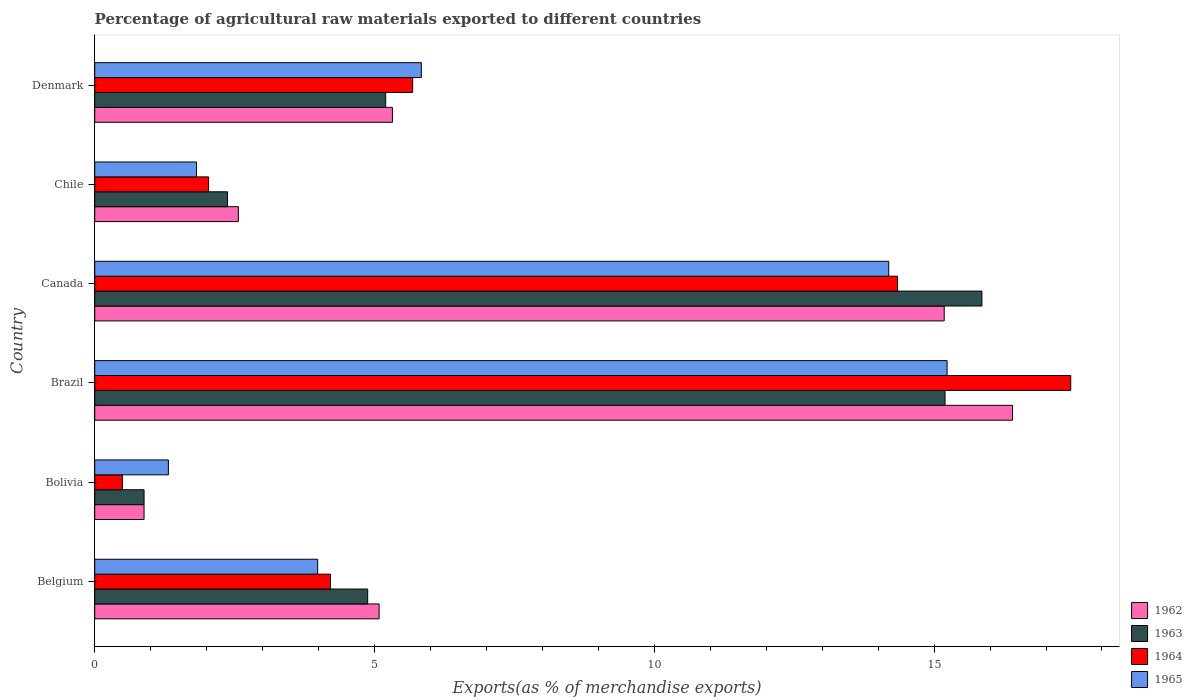How many groups of bars are there?
Offer a very short reply. 6. Are the number of bars per tick equal to the number of legend labels?
Offer a very short reply. Yes. How many bars are there on the 5th tick from the top?
Your answer should be very brief. 4. How many bars are there on the 1st tick from the bottom?
Give a very brief answer. 4. What is the label of the 2nd group of bars from the top?
Keep it short and to the point. Chile. In how many cases, is the number of bars for a given country not equal to the number of legend labels?
Offer a very short reply. 0. What is the percentage of exports to different countries in 1963 in Belgium?
Keep it short and to the point. 4.88. Across all countries, what is the maximum percentage of exports to different countries in 1962?
Give a very brief answer. 16.4. Across all countries, what is the minimum percentage of exports to different countries in 1965?
Your response must be concise. 1.32. In which country was the percentage of exports to different countries in 1964 maximum?
Make the answer very short. Brazil. What is the total percentage of exports to different countries in 1965 in the graph?
Your answer should be compact. 42.38. What is the difference between the percentage of exports to different countries in 1964 in Belgium and that in Denmark?
Offer a terse response. -1.47. What is the difference between the percentage of exports to different countries in 1962 in Denmark and the percentage of exports to different countries in 1964 in Canada?
Keep it short and to the point. -9.03. What is the average percentage of exports to different countries in 1965 per country?
Offer a very short reply. 7.06. What is the difference between the percentage of exports to different countries in 1963 and percentage of exports to different countries in 1964 in Canada?
Make the answer very short. 1.51. In how many countries, is the percentage of exports to different countries in 1965 greater than 17 %?
Ensure brevity in your answer.  0. What is the ratio of the percentage of exports to different countries in 1963 in Bolivia to that in Brazil?
Provide a short and direct response. 0.06. Is the percentage of exports to different countries in 1964 in Bolivia less than that in Denmark?
Offer a very short reply. Yes. What is the difference between the highest and the second highest percentage of exports to different countries in 1964?
Offer a terse response. 3.1. What is the difference between the highest and the lowest percentage of exports to different countries in 1963?
Your answer should be compact. 14.97. In how many countries, is the percentage of exports to different countries in 1965 greater than the average percentage of exports to different countries in 1965 taken over all countries?
Provide a succinct answer. 2. What does the 3rd bar from the top in Belgium represents?
Offer a terse response. 1963. What does the 1st bar from the bottom in Brazil represents?
Provide a succinct answer. 1962. How many countries are there in the graph?
Offer a terse response. 6. What is the difference between two consecutive major ticks on the X-axis?
Keep it short and to the point. 5. How many legend labels are there?
Ensure brevity in your answer.  4. What is the title of the graph?
Make the answer very short. Percentage of agricultural raw materials exported to different countries. What is the label or title of the X-axis?
Keep it short and to the point. Exports(as % of merchandise exports). What is the Exports(as % of merchandise exports) in 1962 in Belgium?
Your answer should be compact. 5.08. What is the Exports(as % of merchandise exports) of 1963 in Belgium?
Offer a very short reply. 4.88. What is the Exports(as % of merchandise exports) of 1964 in Belgium?
Offer a very short reply. 4.21. What is the Exports(as % of merchandise exports) in 1965 in Belgium?
Provide a short and direct response. 3.98. What is the Exports(as % of merchandise exports) in 1962 in Bolivia?
Offer a terse response. 0.88. What is the Exports(as % of merchandise exports) of 1963 in Bolivia?
Your answer should be very brief. 0.88. What is the Exports(as % of merchandise exports) in 1964 in Bolivia?
Your answer should be compact. 0.49. What is the Exports(as % of merchandise exports) of 1965 in Bolivia?
Keep it short and to the point. 1.32. What is the Exports(as % of merchandise exports) in 1962 in Brazil?
Offer a terse response. 16.4. What is the Exports(as % of merchandise exports) in 1963 in Brazil?
Your answer should be very brief. 15.2. What is the Exports(as % of merchandise exports) in 1964 in Brazil?
Offer a terse response. 17.44. What is the Exports(as % of merchandise exports) of 1965 in Brazil?
Offer a terse response. 15.23. What is the Exports(as % of merchandise exports) of 1962 in Canada?
Ensure brevity in your answer.  15.18. What is the Exports(as % of merchandise exports) in 1963 in Canada?
Your answer should be compact. 15.85. What is the Exports(as % of merchandise exports) of 1964 in Canada?
Offer a terse response. 14.35. What is the Exports(as % of merchandise exports) of 1965 in Canada?
Provide a succinct answer. 14.19. What is the Exports(as % of merchandise exports) of 1962 in Chile?
Your answer should be compact. 2.57. What is the Exports(as % of merchandise exports) of 1963 in Chile?
Keep it short and to the point. 2.37. What is the Exports(as % of merchandise exports) in 1964 in Chile?
Ensure brevity in your answer.  2.03. What is the Exports(as % of merchandise exports) of 1965 in Chile?
Provide a short and direct response. 1.82. What is the Exports(as % of merchandise exports) in 1962 in Denmark?
Your answer should be very brief. 5.32. What is the Exports(as % of merchandise exports) of 1963 in Denmark?
Provide a short and direct response. 5.2. What is the Exports(as % of merchandise exports) of 1964 in Denmark?
Your answer should be compact. 5.68. What is the Exports(as % of merchandise exports) in 1965 in Denmark?
Make the answer very short. 5.84. Across all countries, what is the maximum Exports(as % of merchandise exports) of 1962?
Offer a terse response. 16.4. Across all countries, what is the maximum Exports(as % of merchandise exports) of 1963?
Your response must be concise. 15.85. Across all countries, what is the maximum Exports(as % of merchandise exports) of 1964?
Provide a short and direct response. 17.44. Across all countries, what is the maximum Exports(as % of merchandise exports) in 1965?
Your answer should be very brief. 15.23. Across all countries, what is the minimum Exports(as % of merchandise exports) in 1962?
Keep it short and to the point. 0.88. Across all countries, what is the minimum Exports(as % of merchandise exports) of 1963?
Offer a very short reply. 0.88. Across all countries, what is the minimum Exports(as % of merchandise exports) of 1964?
Your answer should be very brief. 0.49. Across all countries, what is the minimum Exports(as % of merchandise exports) of 1965?
Keep it short and to the point. 1.32. What is the total Exports(as % of merchandise exports) of 1962 in the graph?
Your answer should be very brief. 45.43. What is the total Exports(as % of merchandise exports) of 1963 in the graph?
Your answer should be very brief. 44.38. What is the total Exports(as % of merchandise exports) in 1964 in the graph?
Provide a short and direct response. 44.21. What is the total Exports(as % of merchandise exports) in 1965 in the graph?
Provide a short and direct response. 42.38. What is the difference between the Exports(as % of merchandise exports) in 1962 in Belgium and that in Bolivia?
Offer a very short reply. 4.2. What is the difference between the Exports(as % of merchandise exports) in 1963 in Belgium and that in Bolivia?
Your answer should be very brief. 4. What is the difference between the Exports(as % of merchandise exports) of 1964 in Belgium and that in Bolivia?
Keep it short and to the point. 3.72. What is the difference between the Exports(as % of merchandise exports) of 1965 in Belgium and that in Bolivia?
Ensure brevity in your answer.  2.67. What is the difference between the Exports(as % of merchandise exports) in 1962 in Belgium and that in Brazil?
Make the answer very short. -11.32. What is the difference between the Exports(as % of merchandise exports) of 1963 in Belgium and that in Brazil?
Keep it short and to the point. -10.32. What is the difference between the Exports(as % of merchandise exports) of 1964 in Belgium and that in Brazil?
Your answer should be compact. -13.23. What is the difference between the Exports(as % of merchandise exports) in 1965 in Belgium and that in Brazil?
Provide a short and direct response. -11.25. What is the difference between the Exports(as % of merchandise exports) of 1962 in Belgium and that in Canada?
Offer a very short reply. -10.1. What is the difference between the Exports(as % of merchandise exports) of 1963 in Belgium and that in Canada?
Ensure brevity in your answer.  -10.98. What is the difference between the Exports(as % of merchandise exports) in 1964 in Belgium and that in Canada?
Offer a terse response. -10.13. What is the difference between the Exports(as % of merchandise exports) of 1965 in Belgium and that in Canada?
Provide a succinct answer. -10.21. What is the difference between the Exports(as % of merchandise exports) in 1962 in Belgium and that in Chile?
Offer a terse response. 2.52. What is the difference between the Exports(as % of merchandise exports) in 1963 in Belgium and that in Chile?
Your answer should be very brief. 2.5. What is the difference between the Exports(as % of merchandise exports) in 1964 in Belgium and that in Chile?
Give a very brief answer. 2.18. What is the difference between the Exports(as % of merchandise exports) in 1965 in Belgium and that in Chile?
Offer a very short reply. 2.17. What is the difference between the Exports(as % of merchandise exports) in 1962 in Belgium and that in Denmark?
Make the answer very short. -0.24. What is the difference between the Exports(as % of merchandise exports) of 1963 in Belgium and that in Denmark?
Your answer should be very brief. -0.32. What is the difference between the Exports(as % of merchandise exports) of 1964 in Belgium and that in Denmark?
Make the answer very short. -1.47. What is the difference between the Exports(as % of merchandise exports) in 1965 in Belgium and that in Denmark?
Offer a terse response. -1.85. What is the difference between the Exports(as % of merchandise exports) of 1962 in Bolivia and that in Brazil?
Keep it short and to the point. -15.52. What is the difference between the Exports(as % of merchandise exports) of 1963 in Bolivia and that in Brazil?
Keep it short and to the point. -14.31. What is the difference between the Exports(as % of merchandise exports) in 1964 in Bolivia and that in Brazil?
Offer a terse response. -16.95. What is the difference between the Exports(as % of merchandise exports) of 1965 in Bolivia and that in Brazil?
Your answer should be very brief. -13.92. What is the difference between the Exports(as % of merchandise exports) of 1962 in Bolivia and that in Canada?
Make the answer very short. -14.3. What is the difference between the Exports(as % of merchandise exports) of 1963 in Bolivia and that in Canada?
Ensure brevity in your answer.  -14.97. What is the difference between the Exports(as % of merchandise exports) in 1964 in Bolivia and that in Canada?
Provide a short and direct response. -13.85. What is the difference between the Exports(as % of merchandise exports) in 1965 in Bolivia and that in Canada?
Give a very brief answer. -12.87. What is the difference between the Exports(as % of merchandise exports) of 1962 in Bolivia and that in Chile?
Your answer should be very brief. -1.69. What is the difference between the Exports(as % of merchandise exports) of 1963 in Bolivia and that in Chile?
Offer a very short reply. -1.49. What is the difference between the Exports(as % of merchandise exports) of 1964 in Bolivia and that in Chile?
Provide a short and direct response. -1.54. What is the difference between the Exports(as % of merchandise exports) of 1965 in Bolivia and that in Chile?
Offer a very short reply. -0.5. What is the difference between the Exports(as % of merchandise exports) in 1962 in Bolivia and that in Denmark?
Your answer should be very brief. -4.44. What is the difference between the Exports(as % of merchandise exports) of 1963 in Bolivia and that in Denmark?
Your answer should be very brief. -4.32. What is the difference between the Exports(as % of merchandise exports) in 1964 in Bolivia and that in Denmark?
Ensure brevity in your answer.  -5.19. What is the difference between the Exports(as % of merchandise exports) of 1965 in Bolivia and that in Denmark?
Make the answer very short. -4.52. What is the difference between the Exports(as % of merchandise exports) of 1962 in Brazil and that in Canada?
Provide a succinct answer. 1.22. What is the difference between the Exports(as % of merchandise exports) in 1963 in Brazil and that in Canada?
Offer a terse response. -0.66. What is the difference between the Exports(as % of merchandise exports) in 1964 in Brazil and that in Canada?
Provide a short and direct response. 3.1. What is the difference between the Exports(as % of merchandise exports) in 1965 in Brazil and that in Canada?
Your answer should be compact. 1.04. What is the difference between the Exports(as % of merchandise exports) in 1962 in Brazil and that in Chile?
Your response must be concise. 13.84. What is the difference between the Exports(as % of merchandise exports) in 1963 in Brazil and that in Chile?
Provide a short and direct response. 12.82. What is the difference between the Exports(as % of merchandise exports) in 1964 in Brazil and that in Chile?
Your answer should be compact. 15.41. What is the difference between the Exports(as % of merchandise exports) in 1965 in Brazil and that in Chile?
Provide a short and direct response. 13.41. What is the difference between the Exports(as % of merchandise exports) in 1962 in Brazil and that in Denmark?
Offer a very short reply. 11.08. What is the difference between the Exports(as % of merchandise exports) of 1963 in Brazil and that in Denmark?
Keep it short and to the point. 10. What is the difference between the Exports(as % of merchandise exports) of 1964 in Brazil and that in Denmark?
Ensure brevity in your answer.  11.76. What is the difference between the Exports(as % of merchandise exports) of 1965 in Brazil and that in Denmark?
Offer a terse response. 9.4. What is the difference between the Exports(as % of merchandise exports) in 1962 in Canada and that in Chile?
Offer a terse response. 12.61. What is the difference between the Exports(as % of merchandise exports) in 1963 in Canada and that in Chile?
Provide a succinct answer. 13.48. What is the difference between the Exports(as % of merchandise exports) of 1964 in Canada and that in Chile?
Make the answer very short. 12.31. What is the difference between the Exports(as % of merchandise exports) of 1965 in Canada and that in Chile?
Ensure brevity in your answer.  12.37. What is the difference between the Exports(as % of merchandise exports) in 1962 in Canada and that in Denmark?
Provide a short and direct response. 9.86. What is the difference between the Exports(as % of merchandise exports) of 1963 in Canada and that in Denmark?
Your response must be concise. 10.65. What is the difference between the Exports(as % of merchandise exports) of 1964 in Canada and that in Denmark?
Provide a short and direct response. 8.66. What is the difference between the Exports(as % of merchandise exports) of 1965 in Canada and that in Denmark?
Your answer should be compact. 8.35. What is the difference between the Exports(as % of merchandise exports) of 1962 in Chile and that in Denmark?
Offer a very short reply. -2.75. What is the difference between the Exports(as % of merchandise exports) in 1963 in Chile and that in Denmark?
Offer a terse response. -2.83. What is the difference between the Exports(as % of merchandise exports) in 1964 in Chile and that in Denmark?
Your answer should be compact. -3.65. What is the difference between the Exports(as % of merchandise exports) of 1965 in Chile and that in Denmark?
Your answer should be very brief. -4.02. What is the difference between the Exports(as % of merchandise exports) of 1962 in Belgium and the Exports(as % of merchandise exports) of 1963 in Bolivia?
Keep it short and to the point. 4.2. What is the difference between the Exports(as % of merchandise exports) in 1962 in Belgium and the Exports(as % of merchandise exports) in 1964 in Bolivia?
Provide a short and direct response. 4.59. What is the difference between the Exports(as % of merchandise exports) in 1962 in Belgium and the Exports(as % of merchandise exports) in 1965 in Bolivia?
Provide a succinct answer. 3.77. What is the difference between the Exports(as % of merchandise exports) of 1963 in Belgium and the Exports(as % of merchandise exports) of 1964 in Bolivia?
Your answer should be very brief. 4.38. What is the difference between the Exports(as % of merchandise exports) of 1963 in Belgium and the Exports(as % of merchandise exports) of 1965 in Bolivia?
Provide a succinct answer. 3.56. What is the difference between the Exports(as % of merchandise exports) in 1964 in Belgium and the Exports(as % of merchandise exports) in 1965 in Bolivia?
Your answer should be very brief. 2.9. What is the difference between the Exports(as % of merchandise exports) of 1962 in Belgium and the Exports(as % of merchandise exports) of 1963 in Brazil?
Give a very brief answer. -10.11. What is the difference between the Exports(as % of merchandise exports) in 1962 in Belgium and the Exports(as % of merchandise exports) in 1964 in Brazil?
Provide a short and direct response. -12.36. What is the difference between the Exports(as % of merchandise exports) in 1962 in Belgium and the Exports(as % of merchandise exports) in 1965 in Brazil?
Ensure brevity in your answer.  -10.15. What is the difference between the Exports(as % of merchandise exports) in 1963 in Belgium and the Exports(as % of merchandise exports) in 1964 in Brazil?
Offer a very short reply. -12.56. What is the difference between the Exports(as % of merchandise exports) of 1963 in Belgium and the Exports(as % of merchandise exports) of 1965 in Brazil?
Offer a very short reply. -10.35. What is the difference between the Exports(as % of merchandise exports) of 1964 in Belgium and the Exports(as % of merchandise exports) of 1965 in Brazil?
Your answer should be compact. -11.02. What is the difference between the Exports(as % of merchandise exports) of 1962 in Belgium and the Exports(as % of merchandise exports) of 1963 in Canada?
Keep it short and to the point. -10.77. What is the difference between the Exports(as % of merchandise exports) of 1962 in Belgium and the Exports(as % of merchandise exports) of 1964 in Canada?
Make the answer very short. -9.26. What is the difference between the Exports(as % of merchandise exports) of 1962 in Belgium and the Exports(as % of merchandise exports) of 1965 in Canada?
Make the answer very short. -9.11. What is the difference between the Exports(as % of merchandise exports) of 1963 in Belgium and the Exports(as % of merchandise exports) of 1964 in Canada?
Provide a succinct answer. -9.47. What is the difference between the Exports(as % of merchandise exports) of 1963 in Belgium and the Exports(as % of merchandise exports) of 1965 in Canada?
Provide a short and direct response. -9.31. What is the difference between the Exports(as % of merchandise exports) of 1964 in Belgium and the Exports(as % of merchandise exports) of 1965 in Canada?
Offer a very short reply. -9.98. What is the difference between the Exports(as % of merchandise exports) in 1962 in Belgium and the Exports(as % of merchandise exports) in 1963 in Chile?
Offer a terse response. 2.71. What is the difference between the Exports(as % of merchandise exports) of 1962 in Belgium and the Exports(as % of merchandise exports) of 1964 in Chile?
Your response must be concise. 3.05. What is the difference between the Exports(as % of merchandise exports) of 1962 in Belgium and the Exports(as % of merchandise exports) of 1965 in Chile?
Give a very brief answer. 3.26. What is the difference between the Exports(as % of merchandise exports) in 1963 in Belgium and the Exports(as % of merchandise exports) in 1964 in Chile?
Provide a short and direct response. 2.84. What is the difference between the Exports(as % of merchandise exports) in 1963 in Belgium and the Exports(as % of merchandise exports) in 1965 in Chile?
Provide a short and direct response. 3.06. What is the difference between the Exports(as % of merchandise exports) of 1964 in Belgium and the Exports(as % of merchandise exports) of 1965 in Chile?
Offer a very short reply. 2.4. What is the difference between the Exports(as % of merchandise exports) in 1962 in Belgium and the Exports(as % of merchandise exports) in 1963 in Denmark?
Offer a very short reply. -0.12. What is the difference between the Exports(as % of merchandise exports) in 1962 in Belgium and the Exports(as % of merchandise exports) in 1964 in Denmark?
Offer a very short reply. -0.6. What is the difference between the Exports(as % of merchandise exports) in 1962 in Belgium and the Exports(as % of merchandise exports) in 1965 in Denmark?
Your answer should be compact. -0.75. What is the difference between the Exports(as % of merchandise exports) of 1963 in Belgium and the Exports(as % of merchandise exports) of 1964 in Denmark?
Offer a terse response. -0.8. What is the difference between the Exports(as % of merchandise exports) in 1963 in Belgium and the Exports(as % of merchandise exports) in 1965 in Denmark?
Your answer should be very brief. -0.96. What is the difference between the Exports(as % of merchandise exports) in 1964 in Belgium and the Exports(as % of merchandise exports) in 1965 in Denmark?
Provide a short and direct response. -1.62. What is the difference between the Exports(as % of merchandise exports) in 1962 in Bolivia and the Exports(as % of merchandise exports) in 1963 in Brazil?
Your response must be concise. -14.31. What is the difference between the Exports(as % of merchandise exports) of 1962 in Bolivia and the Exports(as % of merchandise exports) of 1964 in Brazil?
Offer a terse response. -16.56. What is the difference between the Exports(as % of merchandise exports) of 1962 in Bolivia and the Exports(as % of merchandise exports) of 1965 in Brazil?
Offer a terse response. -14.35. What is the difference between the Exports(as % of merchandise exports) of 1963 in Bolivia and the Exports(as % of merchandise exports) of 1964 in Brazil?
Give a very brief answer. -16.56. What is the difference between the Exports(as % of merchandise exports) in 1963 in Bolivia and the Exports(as % of merchandise exports) in 1965 in Brazil?
Give a very brief answer. -14.35. What is the difference between the Exports(as % of merchandise exports) in 1964 in Bolivia and the Exports(as % of merchandise exports) in 1965 in Brazil?
Your answer should be compact. -14.74. What is the difference between the Exports(as % of merchandise exports) of 1962 in Bolivia and the Exports(as % of merchandise exports) of 1963 in Canada?
Provide a short and direct response. -14.97. What is the difference between the Exports(as % of merchandise exports) in 1962 in Bolivia and the Exports(as % of merchandise exports) in 1964 in Canada?
Offer a very short reply. -13.46. What is the difference between the Exports(as % of merchandise exports) in 1962 in Bolivia and the Exports(as % of merchandise exports) in 1965 in Canada?
Your answer should be very brief. -13.31. What is the difference between the Exports(as % of merchandise exports) of 1963 in Bolivia and the Exports(as % of merchandise exports) of 1964 in Canada?
Provide a succinct answer. -13.46. What is the difference between the Exports(as % of merchandise exports) of 1963 in Bolivia and the Exports(as % of merchandise exports) of 1965 in Canada?
Your response must be concise. -13.31. What is the difference between the Exports(as % of merchandise exports) in 1964 in Bolivia and the Exports(as % of merchandise exports) in 1965 in Canada?
Provide a short and direct response. -13.7. What is the difference between the Exports(as % of merchandise exports) in 1962 in Bolivia and the Exports(as % of merchandise exports) in 1963 in Chile?
Give a very brief answer. -1.49. What is the difference between the Exports(as % of merchandise exports) of 1962 in Bolivia and the Exports(as % of merchandise exports) of 1964 in Chile?
Make the answer very short. -1.15. What is the difference between the Exports(as % of merchandise exports) of 1962 in Bolivia and the Exports(as % of merchandise exports) of 1965 in Chile?
Provide a succinct answer. -0.94. What is the difference between the Exports(as % of merchandise exports) in 1963 in Bolivia and the Exports(as % of merchandise exports) in 1964 in Chile?
Provide a short and direct response. -1.15. What is the difference between the Exports(as % of merchandise exports) of 1963 in Bolivia and the Exports(as % of merchandise exports) of 1965 in Chile?
Offer a terse response. -0.94. What is the difference between the Exports(as % of merchandise exports) in 1964 in Bolivia and the Exports(as % of merchandise exports) in 1965 in Chile?
Your response must be concise. -1.32. What is the difference between the Exports(as % of merchandise exports) in 1962 in Bolivia and the Exports(as % of merchandise exports) in 1963 in Denmark?
Keep it short and to the point. -4.32. What is the difference between the Exports(as % of merchandise exports) of 1962 in Bolivia and the Exports(as % of merchandise exports) of 1964 in Denmark?
Provide a succinct answer. -4.8. What is the difference between the Exports(as % of merchandise exports) of 1962 in Bolivia and the Exports(as % of merchandise exports) of 1965 in Denmark?
Your answer should be compact. -4.95. What is the difference between the Exports(as % of merchandise exports) in 1963 in Bolivia and the Exports(as % of merchandise exports) in 1964 in Denmark?
Provide a short and direct response. -4.8. What is the difference between the Exports(as % of merchandise exports) in 1963 in Bolivia and the Exports(as % of merchandise exports) in 1965 in Denmark?
Make the answer very short. -4.95. What is the difference between the Exports(as % of merchandise exports) of 1964 in Bolivia and the Exports(as % of merchandise exports) of 1965 in Denmark?
Your response must be concise. -5.34. What is the difference between the Exports(as % of merchandise exports) in 1962 in Brazil and the Exports(as % of merchandise exports) in 1963 in Canada?
Offer a very short reply. 0.55. What is the difference between the Exports(as % of merchandise exports) of 1962 in Brazil and the Exports(as % of merchandise exports) of 1964 in Canada?
Keep it short and to the point. 2.06. What is the difference between the Exports(as % of merchandise exports) of 1962 in Brazil and the Exports(as % of merchandise exports) of 1965 in Canada?
Your answer should be compact. 2.21. What is the difference between the Exports(as % of merchandise exports) in 1963 in Brazil and the Exports(as % of merchandise exports) in 1964 in Canada?
Offer a very short reply. 0.85. What is the difference between the Exports(as % of merchandise exports) in 1963 in Brazil and the Exports(as % of merchandise exports) in 1965 in Canada?
Your response must be concise. 1.01. What is the difference between the Exports(as % of merchandise exports) of 1964 in Brazil and the Exports(as % of merchandise exports) of 1965 in Canada?
Make the answer very short. 3.25. What is the difference between the Exports(as % of merchandise exports) in 1962 in Brazil and the Exports(as % of merchandise exports) in 1963 in Chile?
Your response must be concise. 14.03. What is the difference between the Exports(as % of merchandise exports) of 1962 in Brazil and the Exports(as % of merchandise exports) of 1964 in Chile?
Ensure brevity in your answer.  14.37. What is the difference between the Exports(as % of merchandise exports) of 1962 in Brazil and the Exports(as % of merchandise exports) of 1965 in Chile?
Offer a very short reply. 14.58. What is the difference between the Exports(as % of merchandise exports) in 1963 in Brazil and the Exports(as % of merchandise exports) in 1964 in Chile?
Offer a very short reply. 13.16. What is the difference between the Exports(as % of merchandise exports) of 1963 in Brazil and the Exports(as % of merchandise exports) of 1965 in Chile?
Keep it short and to the point. 13.38. What is the difference between the Exports(as % of merchandise exports) in 1964 in Brazil and the Exports(as % of merchandise exports) in 1965 in Chile?
Your answer should be compact. 15.62. What is the difference between the Exports(as % of merchandise exports) of 1962 in Brazil and the Exports(as % of merchandise exports) of 1963 in Denmark?
Your answer should be very brief. 11.2. What is the difference between the Exports(as % of merchandise exports) of 1962 in Brazil and the Exports(as % of merchandise exports) of 1964 in Denmark?
Your answer should be compact. 10.72. What is the difference between the Exports(as % of merchandise exports) in 1962 in Brazil and the Exports(as % of merchandise exports) in 1965 in Denmark?
Offer a very short reply. 10.57. What is the difference between the Exports(as % of merchandise exports) of 1963 in Brazil and the Exports(as % of merchandise exports) of 1964 in Denmark?
Your response must be concise. 9.51. What is the difference between the Exports(as % of merchandise exports) in 1963 in Brazil and the Exports(as % of merchandise exports) in 1965 in Denmark?
Your answer should be compact. 9.36. What is the difference between the Exports(as % of merchandise exports) of 1964 in Brazil and the Exports(as % of merchandise exports) of 1965 in Denmark?
Provide a succinct answer. 11.61. What is the difference between the Exports(as % of merchandise exports) of 1962 in Canada and the Exports(as % of merchandise exports) of 1963 in Chile?
Offer a very short reply. 12.81. What is the difference between the Exports(as % of merchandise exports) of 1962 in Canada and the Exports(as % of merchandise exports) of 1964 in Chile?
Give a very brief answer. 13.15. What is the difference between the Exports(as % of merchandise exports) of 1962 in Canada and the Exports(as % of merchandise exports) of 1965 in Chile?
Offer a very short reply. 13.36. What is the difference between the Exports(as % of merchandise exports) of 1963 in Canada and the Exports(as % of merchandise exports) of 1964 in Chile?
Make the answer very short. 13.82. What is the difference between the Exports(as % of merchandise exports) in 1963 in Canada and the Exports(as % of merchandise exports) in 1965 in Chile?
Offer a terse response. 14.04. What is the difference between the Exports(as % of merchandise exports) in 1964 in Canada and the Exports(as % of merchandise exports) in 1965 in Chile?
Keep it short and to the point. 12.53. What is the difference between the Exports(as % of merchandise exports) in 1962 in Canada and the Exports(as % of merchandise exports) in 1963 in Denmark?
Your answer should be very brief. 9.98. What is the difference between the Exports(as % of merchandise exports) in 1962 in Canada and the Exports(as % of merchandise exports) in 1964 in Denmark?
Your response must be concise. 9.5. What is the difference between the Exports(as % of merchandise exports) of 1962 in Canada and the Exports(as % of merchandise exports) of 1965 in Denmark?
Your answer should be compact. 9.34. What is the difference between the Exports(as % of merchandise exports) in 1963 in Canada and the Exports(as % of merchandise exports) in 1964 in Denmark?
Your answer should be compact. 10.17. What is the difference between the Exports(as % of merchandise exports) of 1963 in Canada and the Exports(as % of merchandise exports) of 1965 in Denmark?
Your answer should be compact. 10.02. What is the difference between the Exports(as % of merchandise exports) in 1964 in Canada and the Exports(as % of merchandise exports) in 1965 in Denmark?
Keep it short and to the point. 8.51. What is the difference between the Exports(as % of merchandise exports) in 1962 in Chile and the Exports(as % of merchandise exports) in 1963 in Denmark?
Provide a succinct answer. -2.63. What is the difference between the Exports(as % of merchandise exports) of 1962 in Chile and the Exports(as % of merchandise exports) of 1964 in Denmark?
Ensure brevity in your answer.  -3.11. What is the difference between the Exports(as % of merchandise exports) of 1962 in Chile and the Exports(as % of merchandise exports) of 1965 in Denmark?
Give a very brief answer. -3.27. What is the difference between the Exports(as % of merchandise exports) in 1963 in Chile and the Exports(as % of merchandise exports) in 1964 in Denmark?
Keep it short and to the point. -3.31. What is the difference between the Exports(as % of merchandise exports) of 1963 in Chile and the Exports(as % of merchandise exports) of 1965 in Denmark?
Your answer should be compact. -3.46. What is the difference between the Exports(as % of merchandise exports) in 1964 in Chile and the Exports(as % of merchandise exports) in 1965 in Denmark?
Ensure brevity in your answer.  -3.8. What is the average Exports(as % of merchandise exports) in 1962 per country?
Your answer should be very brief. 7.57. What is the average Exports(as % of merchandise exports) of 1963 per country?
Offer a very short reply. 7.4. What is the average Exports(as % of merchandise exports) in 1964 per country?
Offer a very short reply. 7.37. What is the average Exports(as % of merchandise exports) of 1965 per country?
Provide a succinct answer. 7.06. What is the difference between the Exports(as % of merchandise exports) in 1962 and Exports(as % of merchandise exports) in 1963 in Belgium?
Your answer should be compact. 0.2. What is the difference between the Exports(as % of merchandise exports) in 1962 and Exports(as % of merchandise exports) in 1964 in Belgium?
Your answer should be compact. 0.87. What is the difference between the Exports(as % of merchandise exports) of 1962 and Exports(as % of merchandise exports) of 1965 in Belgium?
Provide a short and direct response. 1.1. What is the difference between the Exports(as % of merchandise exports) in 1963 and Exports(as % of merchandise exports) in 1964 in Belgium?
Your answer should be compact. 0.66. What is the difference between the Exports(as % of merchandise exports) of 1963 and Exports(as % of merchandise exports) of 1965 in Belgium?
Make the answer very short. 0.89. What is the difference between the Exports(as % of merchandise exports) of 1964 and Exports(as % of merchandise exports) of 1965 in Belgium?
Keep it short and to the point. 0.23. What is the difference between the Exports(as % of merchandise exports) of 1962 and Exports(as % of merchandise exports) of 1964 in Bolivia?
Provide a succinct answer. 0.39. What is the difference between the Exports(as % of merchandise exports) of 1962 and Exports(as % of merchandise exports) of 1965 in Bolivia?
Offer a terse response. -0.43. What is the difference between the Exports(as % of merchandise exports) in 1963 and Exports(as % of merchandise exports) in 1964 in Bolivia?
Make the answer very short. 0.39. What is the difference between the Exports(as % of merchandise exports) of 1963 and Exports(as % of merchandise exports) of 1965 in Bolivia?
Provide a short and direct response. -0.43. What is the difference between the Exports(as % of merchandise exports) of 1964 and Exports(as % of merchandise exports) of 1965 in Bolivia?
Provide a short and direct response. -0.82. What is the difference between the Exports(as % of merchandise exports) in 1962 and Exports(as % of merchandise exports) in 1963 in Brazil?
Provide a succinct answer. 1.21. What is the difference between the Exports(as % of merchandise exports) of 1962 and Exports(as % of merchandise exports) of 1964 in Brazil?
Your response must be concise. -1.04. What is the difference between the Exports(as % of merchandise exports) in 1962 and Exports(as % of merchandise exports) in 1965 in Brazil?
Your answer should be very brief. 1.17. What is the difference between the Exports(as % of merchandise exports) of 1963 and Exports(as % of merchandise exports) of 1964 in Brazil?
Keep it short and to the point. -2.25. What is the difference between the Exports(as % of merchandise exports) in 1963 and Exports(as % of merchandise exports) in 1965 in Brazil?
Ensure brevity in your answer.  -0.04. What is the difference between the Exports(as % of merchandise exports) of 1964 and Exports(as % of merchandise exports) of 1965 in Brazil?
Provide a short and direct response. 2.21. What is the difference between the Exports(as % of merchandise exports) of 1962 and Exports(as % of merchandise exports) of 1963 in Canada?
Give a very brief answer. -0.67. What is the difference between the Exports(as % of merchandise exports) of 1962 and Exports(as % of merchandise exports) of 1964 in Canada?
Give a very brief answer. 0.83. What is the difference between the Exports(as % of merchandise exports) in 1962 and Exports(as % of merchandise exports) in 1965 in Canada?
Give a very brief answer. 0.99. What is the difference between the Exports(as % of merchandise exports) in 1963 and Exports(as % of merchandise exports) in 1964 in Canada?
Your response must be concise. 1.51. What is the difference between the Exports(as % of merchandise exports) of 1963 and Exports(as % of merchandise exports) of 1965 in Canada?
Your answer should be compact. 1.67. What is the difference between the Exports(as % of merchandise exports) in 1964 and Exports(as % of merchandise exports) in 1965 in Canada?
Offer a very short reply. 0.16. What is the difference between the Exports(as % of merchandise exports) of 1962 and Exports(as % of merchandise exports) of 1963 in Chile?
Keep it short and to the point. 0.19. What is the difference between the Exports(as % of merchandise exports) of 1962 and Exports(as % of merchandise exports) of 1964 in Chile?
Offer a very short reply. 0.53. What is the difference between the Exports(as % of merchandise exports) of 1962 and Exports(as % of merchandise exports) of 1965 in Chile?
Provide a succinct answer. 0.75. What is the difference between the Exports(as % of merchandise exports) of 1963 and Exports(as % of merchandise exports) of 1964 in Chile?
Ensure brevity in your answer.  0.34. What is the difference between the Exports(as % of merchandise exports) in 1963 and Exports(as % of merchandise exports) in 1965 in Chile?
Give a very brief answer. 0.55. What is the difference between the Exports(as % of merchandise exports) of 1964 and Exports(as % of merchandise exports) of 1965 in Chile?
Offer a terse response. 0.22. What is the difference between the Exports(as % of merchandise exports) in 1962 and Exports(as % of merchandise exports) in 1963 in Denmark?
Make the answer very short. 0.12. What is the difference between the Exports(as % of merchandise exports) in 1962 and Exports(as % of merchandise exports) in 1964 in Denmark?
Give a very brief answer. -0.36. What is the difference between the Exports(as % of merchandise exports) in 1962 and Exports(as % of merchandise exports) in 1965 in Denmark?
Ensure brevity in your answer.  -0.52. What is the difference between the Exports(as % of merchandise exports) of 1963 and Exports(as % of merchandise exports) of 1964 in Denmark?
Provide a short and direct response. -0.48. What is the difference between the Exports(as % of merchandise exports) of 1963 and Exports(as % of merchandise exports) of 1965 in Denmark?
Provide a short and direct response. -0.64. What is the difference between the Exports(as % of merchandise exports) in 1964 and Exports(as % of merchandise exports) in 1965 in Denmark?
Provide a succinct answer. -0.15. What is the ratio of the Exports(as % of merchandise exports) of 1962 in Belgium to that in Bolivia?
Give a very brief answer. 5.77. What is the ratio of the Exports(as % of merchandise exports) of 1963 in Belgium to that in Bolivia?
Keep it short and to the point. 5.53. What is the ratio of the Exports(as % of merchandise exports) of 1964 in Belgium to that in Bolivia?
Provide a short and direct response. 8.52. What is the ratio of the Exports(as % of merchandise exports) in 1965 in Belgium to that in Bolivia?
Your answer should be very brief. 3.03. What is the ratio of the Exports(as % of merchandise exports) in 1962 in Belgium to that in Brazil?
Make the answer very short. 0.31. What is the ratio of the Exports(as % of merchandise exports) in 1963 in Belgium to that in Brazil?
Ensure brevity in your answer.  0.32. What is the ratio of the Exports(as % of merchandise exports) of 1964 in Belgium to that in Brazil?
Keep it short and to the point. 0.24. What is the ratio of the Exports(as % of merchandise exports) of 1965 in Belgium to that in Brazil?
Your response must be concise. 0.26. What is the ratio of the Exports(as % of merchandise exports) in 1962 in Belgium to that in Canada?
Your answer should be compact. 0.33. What is the ratio of the Exports(as % of merchandise exports) in 1963 in Belgium to that in Canada?
Keep it short and to the point. 0.31. What is the ratio of the Exports(as % of merchandise exports) of 1964 in Belgium to that in Canada?
Keep it short and to the point. 0.29. What is the ratio of the Exports(as % of merchandise exports) of 1965 in Belgium to that in Canada?
Provide a short and direct response. 0.28. What is the ratio of the Exports(as % of merchandise exports) of 1962 in Belgium to that in Chile?
Your answer should be compact. 1.98. What is the ratio of the Exports(as % of merchandise exports) in 1963 in Belgium to that in Chile?
Provide a short and direct response. 2.06. What is the ratio of the Exports(as % of merchandise exports) in 1964 in Belgium to that in Chile?
Offer a terse response. 2.07. What is the ratio of the Exports(as % of merchandise exports) of 1965 in Belgium to that in Chile?
Your response must be concise. 2.19. What is the ratio of the Exports(as % of merchandise exports) of 1962 in Belgium to that in Denmark?
Offer a very short reply. 0.96. What is the ratio of the Exports(as % of merchandise exports) in 1963 in Belgium to that in Denmark?
Ensure brevity in your answer.  0.94. What is the ratio of the Exports(as % of merchandise exports) of 1964 in Belgium to that in Denmark?
Provide a succinct answer. 0.74. What is the ratio of the Exports(as % of merchandise exports) of 1965 in Belgium to that in Denmark?
Your answer should be very brief. 0.68. What is the ratio of the Exports(as % of merchandise exports) in 1962 in Bolivia to that in Brazil?
Keep it short and to the point. 0.05. What is the ratio of the Exports(as % of merchandise exports) in 1963 in Bolivia to that in Brazil?
Your answer should be compact. 0.06. What is the ratio of the Exports(as % of merchandise exports) in 1964 in Bolivia to that in Brazil?
Your answer should be compact. 0.03. What is the ratio of the Exports(as % of merchandise exports) of 1965 in Bolivia to that in Brazil?
Provide a short and direct response. 0.09. What is the ratio of the Exports(as % of merchandise exports) in 1962 in Bolivia to that in Canada?
Keep it short and to the point. 0.06. What is the ratio of the Exports(as % of merchandise exports) in 1963 in Bolivia to that in Canada?
Your response must be concise. 0.06. What is the ratio of the Exports(as % of merchandise exports) of 1964 in Bolivia to that in Canada?
Give a very brief answer. 0.03. What is the ratio of the Exports(as % of merchandise exports) of 1965 in Bolivia to that in Canada?
Provide a succinct answer. 0.09. What is the ratio of the Exports(as % of merchandise exports) in 1962 in Bolivia to that in Chile?
Offer a very short reply. 0.34. What is the ratio of the Exports(as % of merchandise exports) in 1963 in Bolivia to that in Chile?
Give a very brief answer. 0.37. What is the ratio of the Exports(as % of merchandise exports) in 1964 in Bolivia to that in Chile?
Ensure brevity in your answer.  0.24. What is the ratio of the Exports(as % of merchandise exports) of 1965 in Bolivia to that in Chile?
Your response must be concise. 0.72. What is the ratio of the Exports(as % of merchandise exports) in 1962 in Bolivia to that in Denmark?
Your answer should be compact. 0.17. What is the ratio of the Exports(as % of merchandise exports) in 1963 in Bolivia to that in Denmark?
Provide a short and direct response. 0.17. What is the ratio of the Exports(as % of merchandise exports) of 1964 in Bolivia to that in Denmark?
Your response must be concise. 0.09. What is the ratio of the Exports(as % of merchandise exports) of 1965 in Bolivia to that in Denmark?
Ensure brevity in your answer.  0.23. What is the ratio of the Exports(as % of merchandise exports) in 1962 in Brazil to that in Canada?
Your response must be concise. 1.08. What is the ratio of the Exports(as % of merchandise exports) in 1963 in Brazil to that in Canada?
Give a very brief answer. 0.96. What is the ratio of the Exports(as % of merchandise exports) in 1964 in Brazil to that in Canada?
Your response must be concise. 1.22. What is the ratio of the Exports(as % of merchandise exports) in 1965 in Brazil to that in Canada?
Keep it short and to the point. 1.07. What is the ratio of the Exports(as % of merchandise exports) of 1962 in Brazil to that in Chile?
Provide a succinct answer. 6.39. What is the ratio of the Exports(as % of merchandise exports) of 1963 in Brazil to that in Chile?
Your answer should be compact. 6.4. What is the ratio of the Exports(as % of merchandise exports) in 1964 in Brazil to that in Chile?
Ensure brevity in your answer.  8.57. What is the ratio of the Exports(as % of merchandise exports) in 1965 in Brazil to that in Chile?
Offer a very short reply. 8.38. What is the ratio of the Exports(as % of merchandise exports) of 1962 in Brazil to that in Denmark?
Offer a very short reply. 3.08. What is the ratio of the Exports(as % of merchandise exports) of 1963 in Brazil to that in Denmark?
Offer a terse response. 2.92. What is the ratio of the Exports(as % of merchandise exports) of 1964 in Brazil to that in Denmark?
Give a very brief answer. 3.07. What is the ratio of the Exports(as % of merchandise exports) in 1965 in Brazil to that in Denmark?
Offer a terse response. 2.61. What is the ratio of the Exports(as % of merchandise exports) in 1962 in Canada to that in Chile?
Your response must be concise. 5.91. What is the ratio of the Exports(as % of merchandise exports) of 1963 in Canada to that in Chile?
Your answer should be very brief. 6.68. What is the ratio of the Exports(as % of merchandise exports) in 1964 in Canada to that in Chile?
Provide a short and direct response. 7.05. What is the ratio of the Exports(as % of merchandise exports) of 1965 in Canada to that in Chile?
Give a very brief answer. 7.8. What is the ratio of the Exports(as % of merchandise exports) in 1962 in Canada to that in Denmark?
Make the answer very short. 2.85. What is the ratio of the Exports(as % of merchandise exports) in 1963 in Canada to that in Denmark?
Your response must be concise. 3.05. What is the ratio of the Exports(as % of merchandise exports) of 1964 in Canada to that in Denmark?
Ensure brevity in your answer.  2.53. What is the ratio of the Exports(as % of merchandise exports) of 1965 in Canada to that in Denmark?
Offer a terse response. 2.43. What is the ratio of the Exports(as % of merchandise exports) of 1962 in Chile to that in Denmark?
Offer a terse response. 0.48. What is the ratio of the Exports(as % of merchandise exports) of 1963 in Chile to that in Denmark?
Offer a very short reply. 0.46. What is the ratio of the Exports(as % of merchandise exports) in 1964 in Chile to that in Denmark?
Your answer should be compact. 0.36. What is the ratio of the Exports(as % of merchandise exports) in 1965 in Chile to that in Denmark?
Keep it short and to the point. 0.31. What is the difference between the highest and the second highest Exports(as % of merchandise exports) of 1962?
Give a very brief answer. 1.22. What is the difference between the highest and the second highest Exports(as % of merchandise exports) of 1963?
Keep it short and to the point. 0.66. What is the difference between the highest and the second highest Exports(as % of merchandise exports) of 1964?
Provide a succinct answer. 3.1. What is the difference between the highest and the second highest Exports(as % of merchandise exports) of 1965?
Provide a short and direct response. 1.04. What is the difference between the highest and the lowest Exports(as % of merchandise exports) of 1962?
Make the answer very short. 15.52. What is the difference between the highest and the lowest Exports(as % of merchandise exports) in 1963?
Give a very brief answer. 14.97. What is the difference between the highest and the lowest Exports(as % of merchandise exports) in 1964?
Provide a short and direct response. 16.95. What is the difference between the highest and the lowest Exports(as % of merchandise exports) of 1965?
Keep it short and to the point. 13.92. 